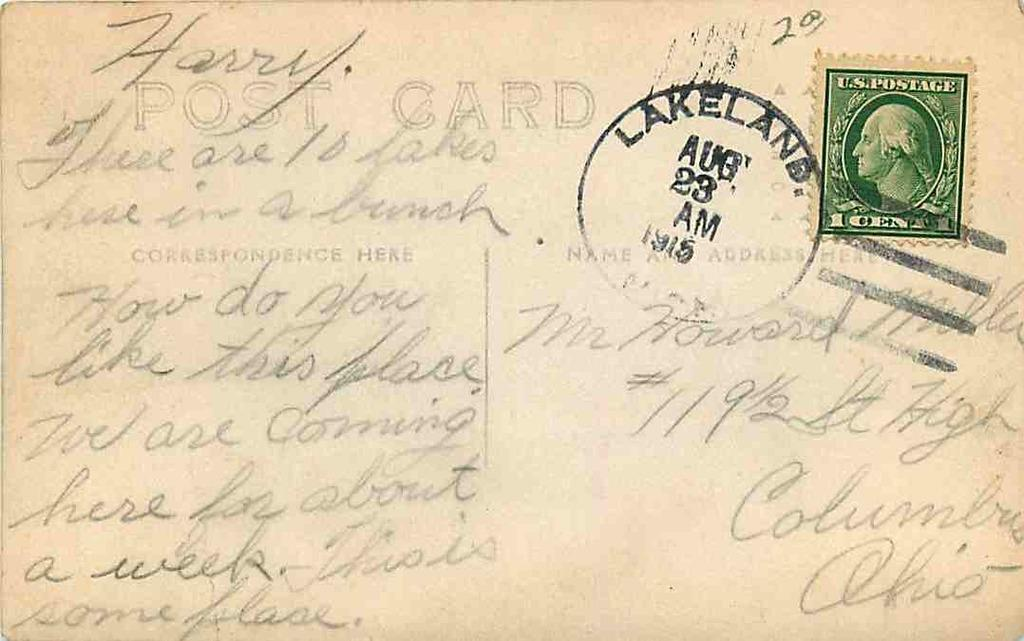<image>
Describe the image concisely. A Post card that has a green money symbol on it of George Washington. 